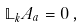Convert formula to latex. <formula><loc_0><loc_0><loc_500><loc_500>\mathbb { L } _ { k } A _ { a } = 0 \, ,</formula> 